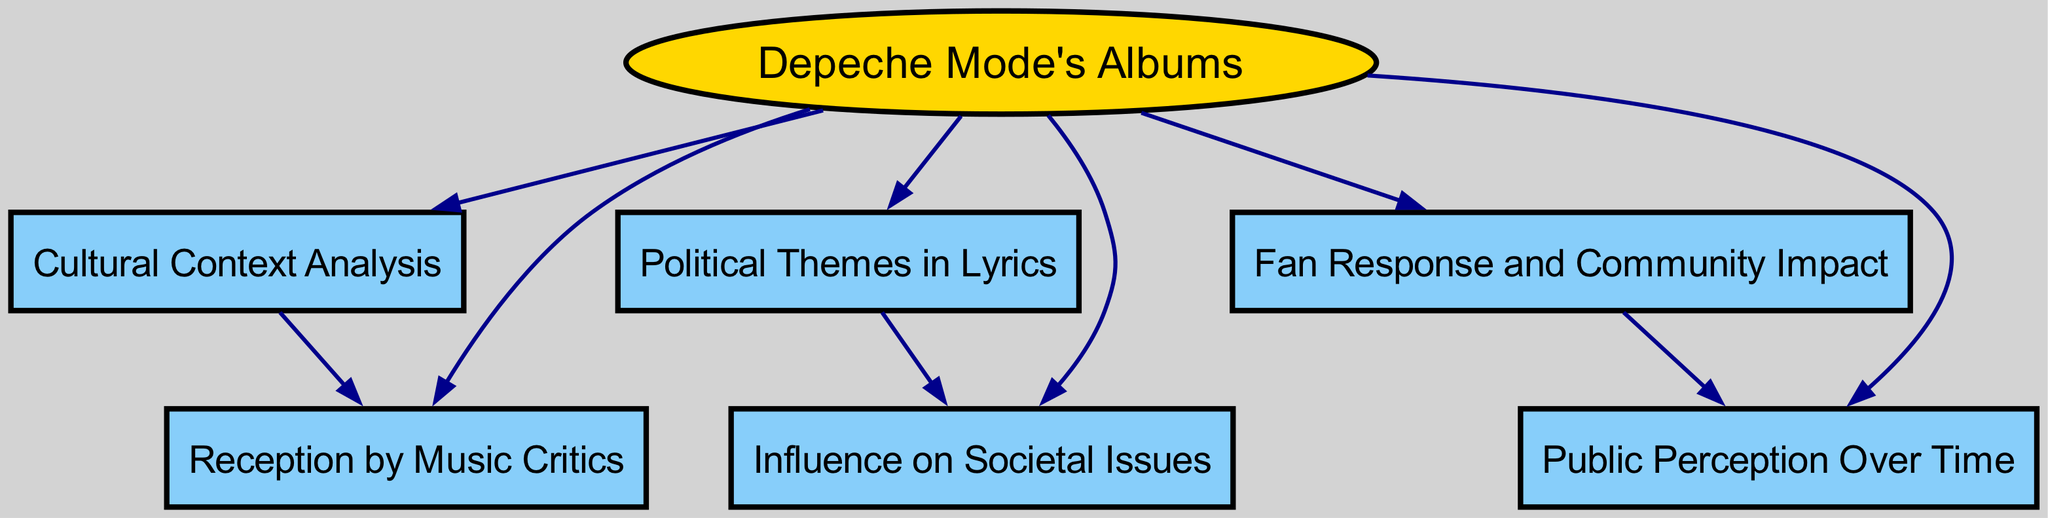What is the total number of nodes in the diagram? The diagram includes nodes labeled "Depeche Mode's Albums", "Cultural Context Analysis", "Political Themes in Lyrics", "Reception by Music Critics", "Fan Response and Community Impact", "Influence on Societal Issues", and "Public Perception Over Time". Counting these, we find there are 7 distinct nodes.
Answer: 7 Which node is directly connected to the "Cultural Context Analysis" node? The "Cultural Context Analysis" node has a directed edge to the "Reception by Music Critics" node, indicating a direct connection between these two nodes. Hence, "Reception by Music Critics" is the answer.
Answer: Reception by Music Critics How many edges originate from the "Depeche Mode's Albums" node? The "Depeche Mode's Albums" node has edges that connect to six other nodes: "Cultural Context Analysis", "Political Themes in Lyrics", "Reception by Music Critics", "Fan Response and Community Impact", "Influence on Societal Issues", and "Public Perception Over Time". Therefore, it has 6 edges originating from it.
Answer: 6 What themes in lyrics influence societal issues? There is a direct edge from the "Political Themes in Lyrics" node to the "Influence on Societal Issues" node. This signifies that the themes found in the lyrics directly impact or correspond with societal issues.
Answer: Political Themes in Lyrics Which two nodes are directly connected to the "Fan Response and Community Impact" node? The "Fan Response and Community Impact" node has a direct connection to the "Public Perception Over Time" node, and it also originates from the "Depeche Mode's Albums" node. Thus, "Public Perception Over Time" is directly connected to it.
Answer: Public Perception Over Time How does cultural context analyze influence the reception of music critics? The "Cultural Context Analysis" node is directly connected to the "Reception by Music Critics" node in the diagram. This indicates that an understanding of cultural context plays a significant role in how critics receive and review the music.
Answer: Reception by Music Critics What is the relationship between "Political Themes in Lyrics" and "Public Perception Over Time"? The "Political Themes in Lyrics" node influences the "Influence on Societal Issues" node. Subsequently, the "Fan Response and Community Impact" node is also connected to "Public Perception Over Time". Thus, the relationship can be traced through societal influence to fan responses, indirectly affecting public perception, but there's no direct connection between them.
Answer: Indirect influence Can you list the nodes that are influenced by "Depeche Mode's Albums"? The "Depeche Mode's Albums" node influences the following nodes: "Cultural Context Analysis", "Political Themes in Lyrics", "Reception by Music Critics", "Fan Response and Community Impact", "Influence on Societal Issues", and "Public Perception Over Time". Listing them sequentially provides an overview of its influence.
Answer: Cultural Context Analysis, Political Themes in Lyrics, Reception by Music Critics, Fan Response and Community Impact, Influence on Societal Issues, Public Perception Over Time 